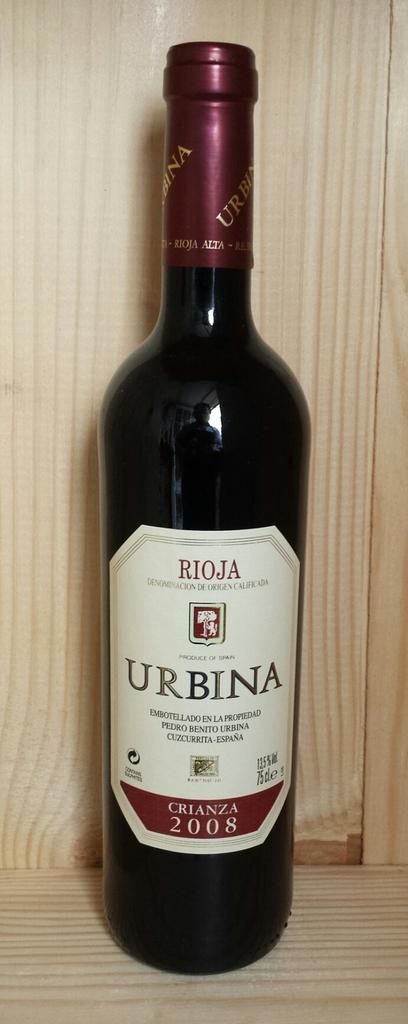What year was this alcohol made?
Ensure brevity in your answer.  2008. What brand of wine is this?
Offer a very short reply. Urbina. 